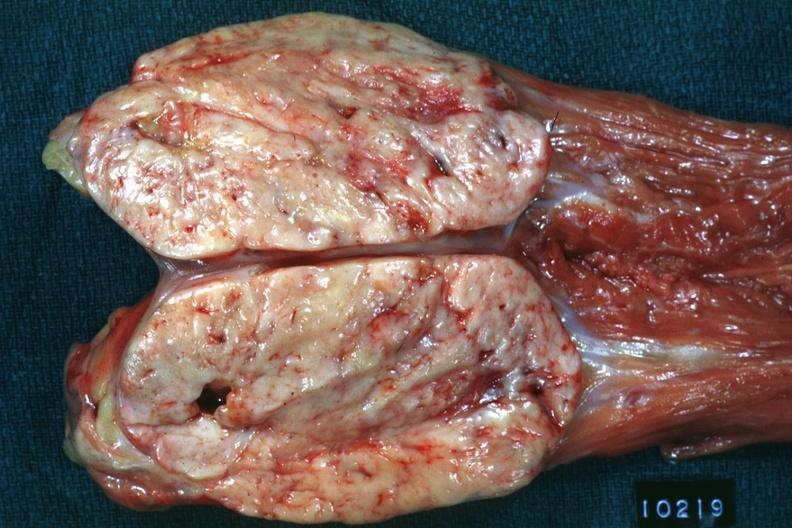what does this image show?
Answer the question using a single word or phrase. Opened muscle probably psoas natural color large ovoid typical sarcoma 